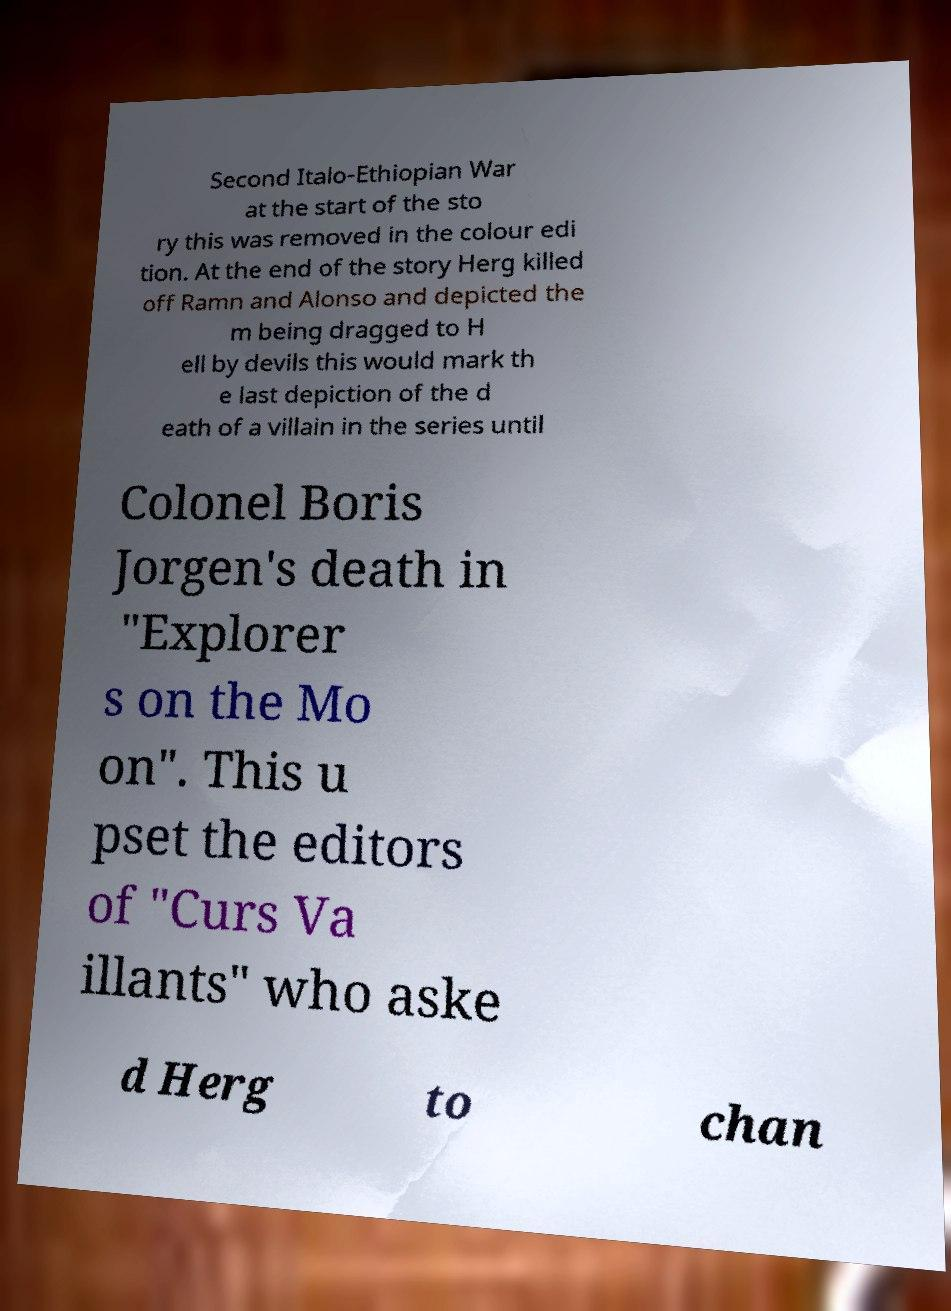What messages or text are displayed in this image? I need them in a readable, typed format. Second Italo-Ethiopian War at the start of the sto ry this was removed in the colour edi tion. At the end of the story Herg killed off Ramn and Alonso and depicted the m being dragged to H ell by devils this would mark th e last depiction of the d eath of a villain in the series until Colonel Boris Jorgen's death in "Explorer s on the Mo on". This u pset the editors of "Curs Va illants" who aske d Herg to chan 